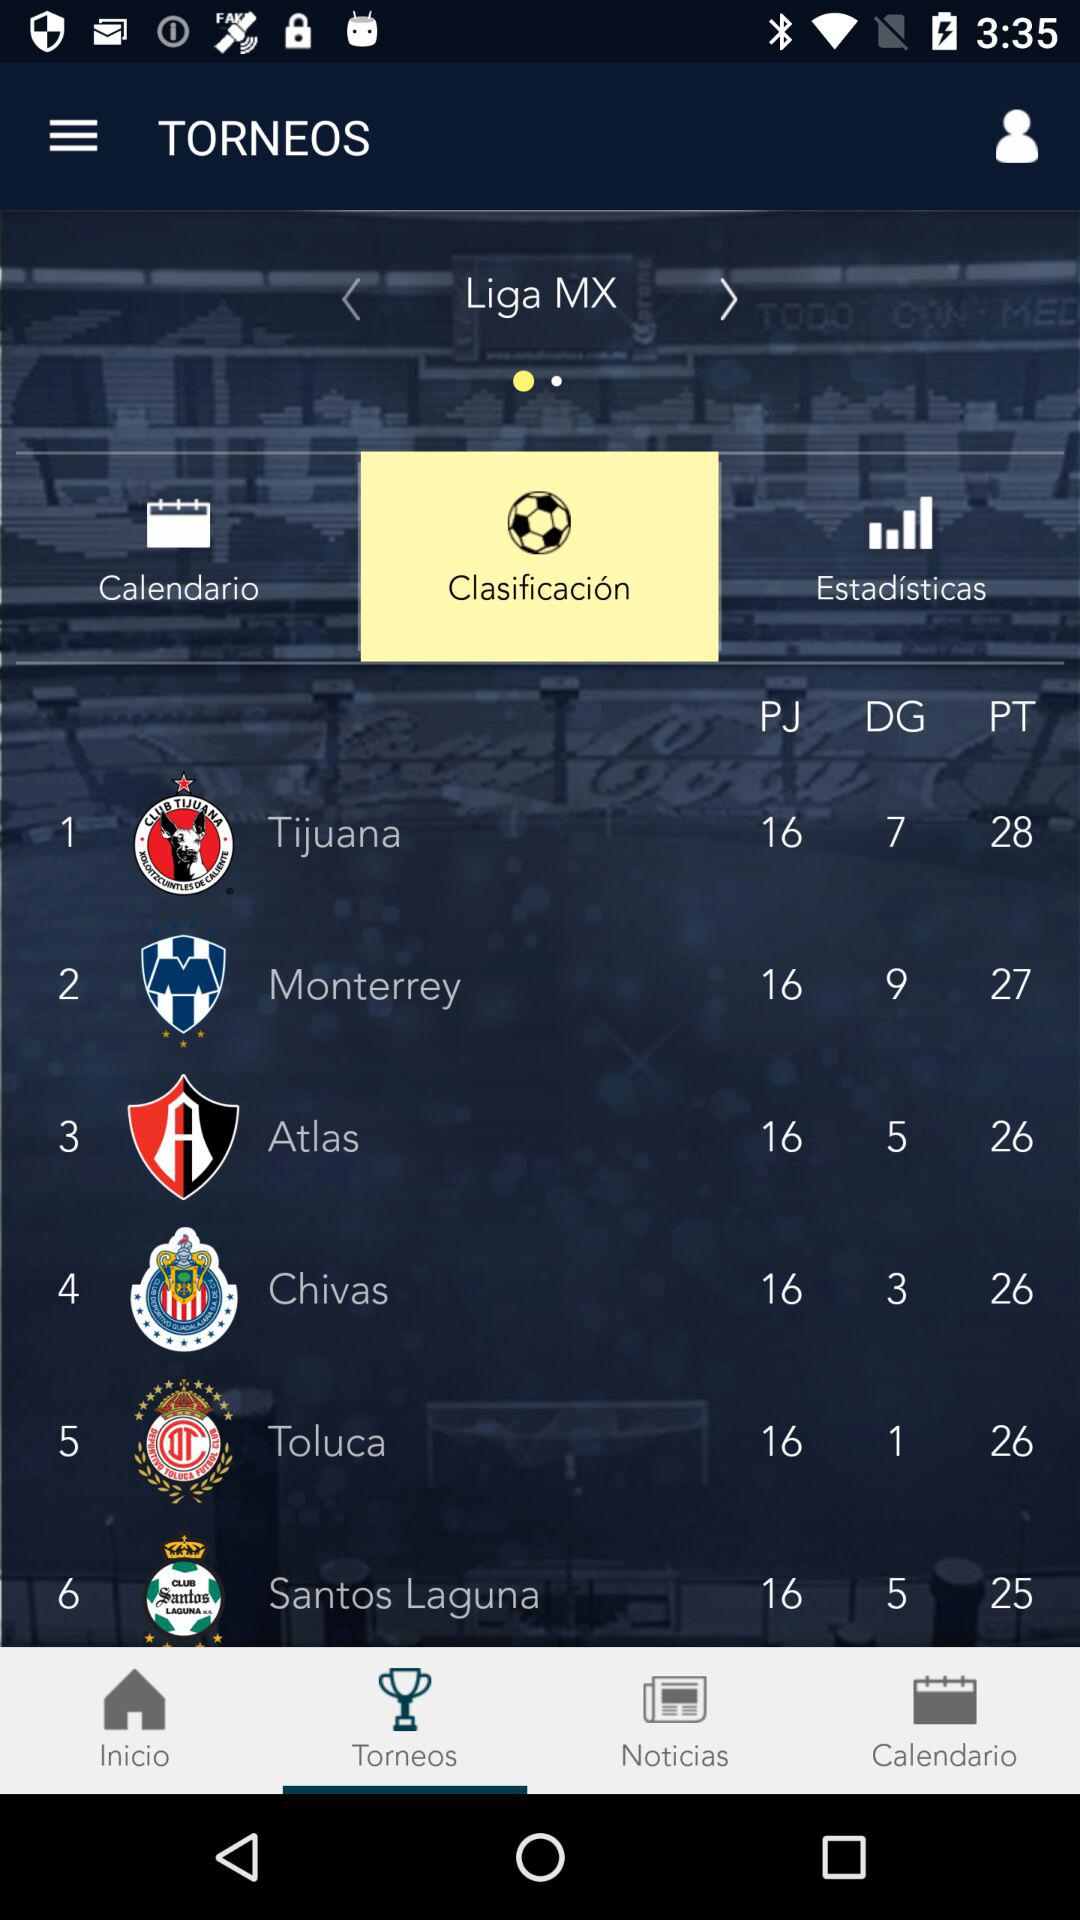What is the application name?
When the provided information is insufficient, respond with <no answer>. <no answer> 